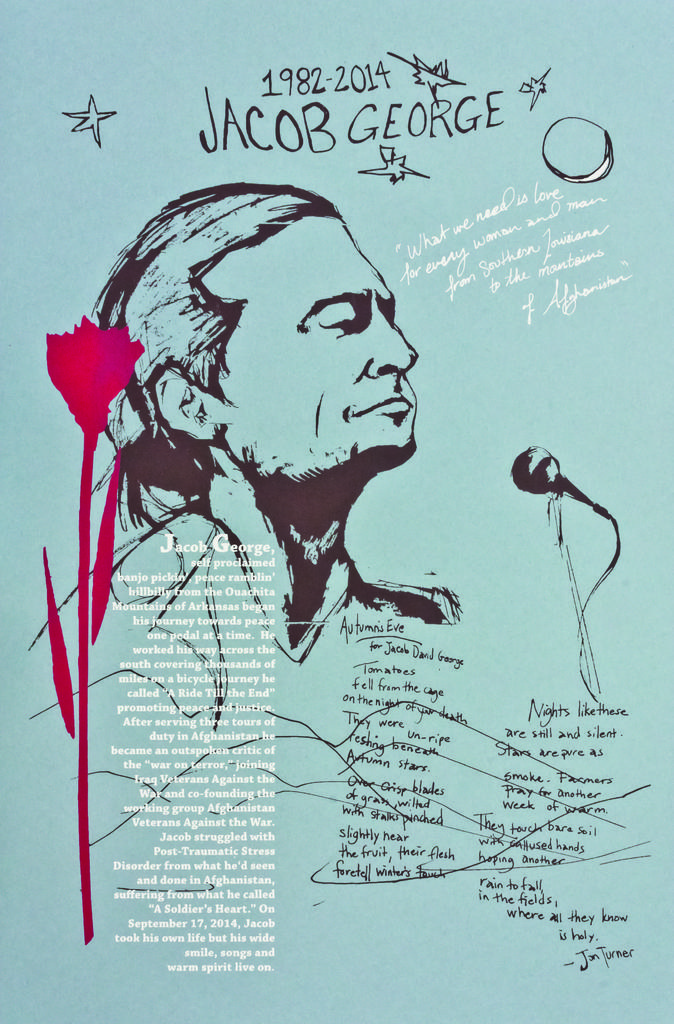What is depicted on the paper in the image? There is a person on the paper, along with a microphone with a stand, a cable, and writing. What color is the paint on the paper? There is red paint on the paper. What might the person on the paper be using the microphone for? It is unclear from the image what the person might be using the microphone for, but it could be for speaking or singing. What is the purpose of the cable on the paper? The cable on the paper might be connected to the microphone to provide power or transmit audio signals. What type of town can be seen in the background of the image? There is no town visible in the image; it only shows a paper with various objects on it. What is the person on the paper using the jar for? There is no jar present in the image; it only shows a paper with various objects on it. 